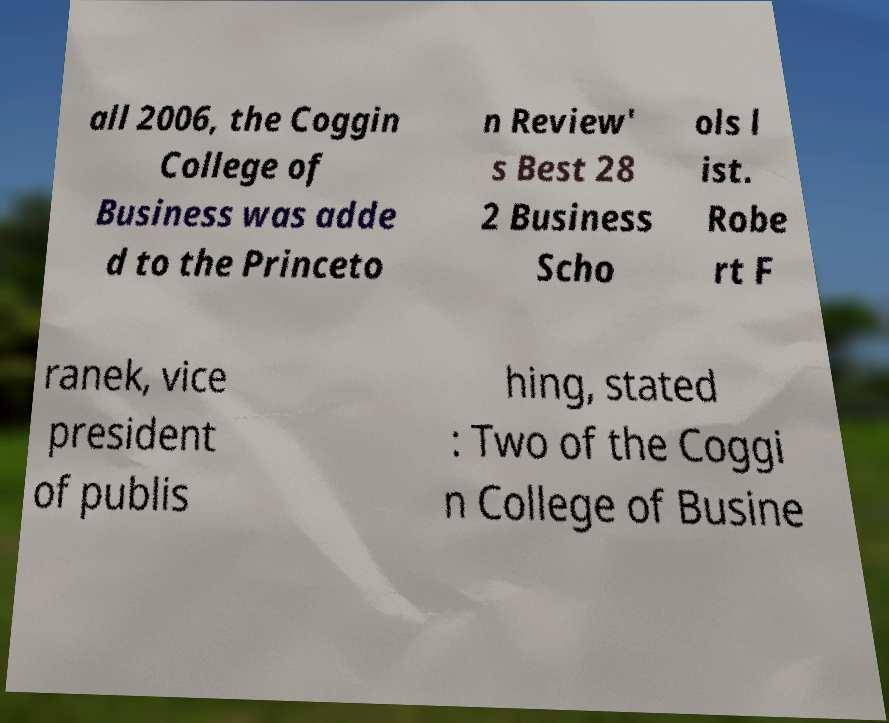Could you extract and type out the text from this image? all 2006, the Coggin College of Business was adde d to the Princeto n Review' s Best 28 2 Business Scho ols l ist. Robe rt F ranek, vice president of publis hing, stated : Two of the Coggi n College of Busine 